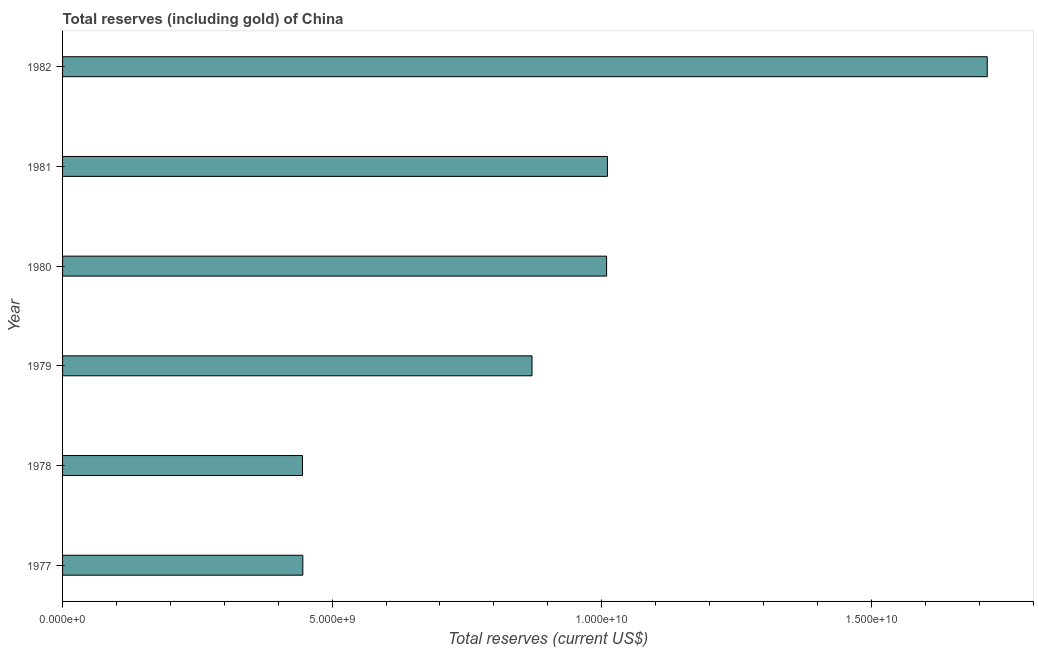Does the graph contain any zero values?
Your answer should be very brief. No. What is the title of the graph?
Your answer should be compact. Total reserves (including gold) of China. What is the label or title of the X-axis?
Your answer should be compact. Total reserves (current US$). What is the total reserves (including gold) in 1982?
Your response must be concise. 1.72e+1. Across all years, what is the maximum total reserves (including gold)?
Offer a very short reply. 1.72e+1. Across all years, what is the minimum total reserves (including gold)?
Keep it short and to the point. 4.45e+09. In which year was the total reserves (including gold) minimum?
Your response must be concise. 1978. What is the sum of the total reserves (including gold)?
Ensure brevity in your answer.  5.50e+1. What is the difference between the total reserves (including gold) in 1977 and 1979?
Offer a terse response. -4.25e+09. What is the average total reserves (including gold) per year?
Give a very brief answer. 9.16e+09. What is the median total reserves (including gold)?
Give a very brief answer. 9.40e+09. What is the ratio of the total reserves (including gold) in 1979 to that in 1981?
Make the answer very short. 0.86. Is the difference between the total reserves (including gold) in 1977 and 1982 greater than the difference between any two years?
Offer a terse response. No. What is the difference between the highest and the second highest total reserves (including gold)?
Make the answer very short. 7.05e+09. Is the sum of the total reserves (including gold) in 1980 and 1982 greater than the maximum total reserves (including gold) across all years?
Give a very brief answer. Yes. What is the difference between the highest and the lowest total reserves (including gold)?
Offer a terse response. 1.27e+1. In how many years, is the total reserves (including gold) greater than the average total reserves (including gold) taken over all years?
Your response must be concise. 3. How many years are there in the graph?
Provide a short and direct response. 6. Are the values on the major ticks of X-axis written in scientific E-notation?
Your answer should be very brief. Yes. What is the Total reserves (current US$) of 1977?
Your answer should be compact. 4.46e+09. What is the Total reserves (current US$) of 1978?
Make the answer very short. 4.45e+09. What is the Total reserves (current US$) of 1979?
Your answer should be compact. 8.71e+09. What is the Total reserves (current US$) in 1980?
Provide a succinct answer. 1.01e+1. What is the Total reserves (current US$) in 1981?
Provide a short and direct response. 1.01e+1. What is the Total reserves (current US$) in 1982?
Ensure brevity in your answer.  1.72e+1. What is the difference between the Total reserves (current US$) in 1977 and 1978?
Your answer should be very brief. 6.56e+06. What is the difference between the Total reserves (current US$) in 1977 and 1979?
Provide a short and direct response. -4.25e+09. What is the difference between the Total reserves (current US$) in 1977 and 1980?
Offer a terse response. -5.63e+09. What is the difference between the Total reserves (current US$) in 1977 and 1981?
Ensure brevity in your answer.  -5.65e+09. What is the difference between the Total reserves (current US$) in 1977 and 1982?
Your answer should be compact. -1.27e+1. What is the difference between the Total reserves (current US$) in 1978 and 1979?
Provide a short and direct response. -4.26e+09. What is the difference between the Total reserves (current US$) in 1978 and 1980?
Keep it short and to the point. -5.64e+09. What is the difference between the Total reserves (current US$) in 1978 and 1981?
Ensure brevity in your answer.  -5.66e+09. What is the difference between the Total reserves (current US$) in 1978 and 1982?
Provide a succinct answer. -1.27e+1. What is the difference between the Total reserves (current US$) in 1979 and 1980?
Make the answer very short. -1.38e+09. What is the difference between the Total reserves (current US$) in 1979 and 1981?
Keep it short and to the point. -1.40e+09. What is the difference between the Total reserves (current US$) in 1979 and 1982?
Keep it short and to the point. -8.44e+09. What is the difference between the Total reserves (current US$) in 1980 and 1981?
Your response must be concise. -1.56e+07. What is the difference between the Total reserves (current US$) in 1980 and 1982?
Ensure brevity in your answer.  -7.06e+09. What is the difference between the Total reserves (current US$) in 1981 and 1982?
Make the answer very short. -7.05e+09. What is the ratio of the Total reserves (current US$) in 1977 to that in 1979?
Your response must be concise. 0.51. What is the ratio of the Total reserves (current US$) in 1977 to that in 1980?
Offer a very short reply. 0.44. What is the ratio of the Total reserves (current US$) in 1977 to that in 1981?
Your answer should be compact. 0.44. What is the ratio of the Total reserves (current US$) in 1977 to that in 1982?
Make the answer very short. 0.26. What is the ratio of the Total reserves (current US$) in 1978 to that in 1979?
Your answer should be compact. 0.51. What is the ratio of the Total reserves (current US$) in 1978 to that in 1980?
Provide a short and direct response. 0.44. What is the ratio of the Total reserves (current US$) in 1978 to that in 1981?
Your answer should be very brief. 0.44. What is the ratio of the Total reserves (current US$) in 1978 to that in 1982?
Your answer should be compact. 0.26. What is the ratio of the Total reserves (current US$) in 1979 to that in 1980?
Give a very brief answer. 0.86. What is the ratio of the Total reserves (current US$) in 1979 to that in 1981?
Keep it short and to the point. 0.86. What is the ratio of the Total reserves (current US$) in 1979 to that in 1982?
Your answer should be compact. 0.51. What is the ratio of the Total reserves (current US$) in 1980 to that in 1981?
Give a very brief answer. 1. What is the ratio of the Total reserves (current US$) in 1980 to that in 1982?
Your response must be concise. 0.59. What is the ratio of the Total reserves (current US$) in 1981 to that in 1982?
Your answer should be very brief. 0.59. 